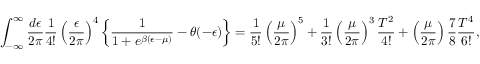<formula> <loc_0><loc_0><loc_500><loc_500>\int _ { - \infty } ^ { \infty } { \frac { d \epsilon } { 2 \pi } } { \frac { 1 } { 4 ! } } \left ( { \frac { \epsilon } { 2 \pi } } \right ) ^ { 4 } \left \{ { \frac { 1 } { 1 + e ^ { \beta ( \epsilon - \mu ) } } } - \theta ( - \epsilon ) \right \} = { \frac { 1 } { 5 ! } } \left ( { \frac { \mu } { 2 \pi } } \right ) ^ { 5 } + { \frac { 1 } { 3 ! } } \left ( { \frac { \mu } { 2 \pi } } \right ) ^ { 3 } { \frac { T ^ { 2 } } { 4 ! } } + \left ( { \frac { \mu } { 2 \pi } } \right ) { \frac { 7 } { 8 } } { \frac { T ^ { 4 } } { 6 ! } } ,</formula> 